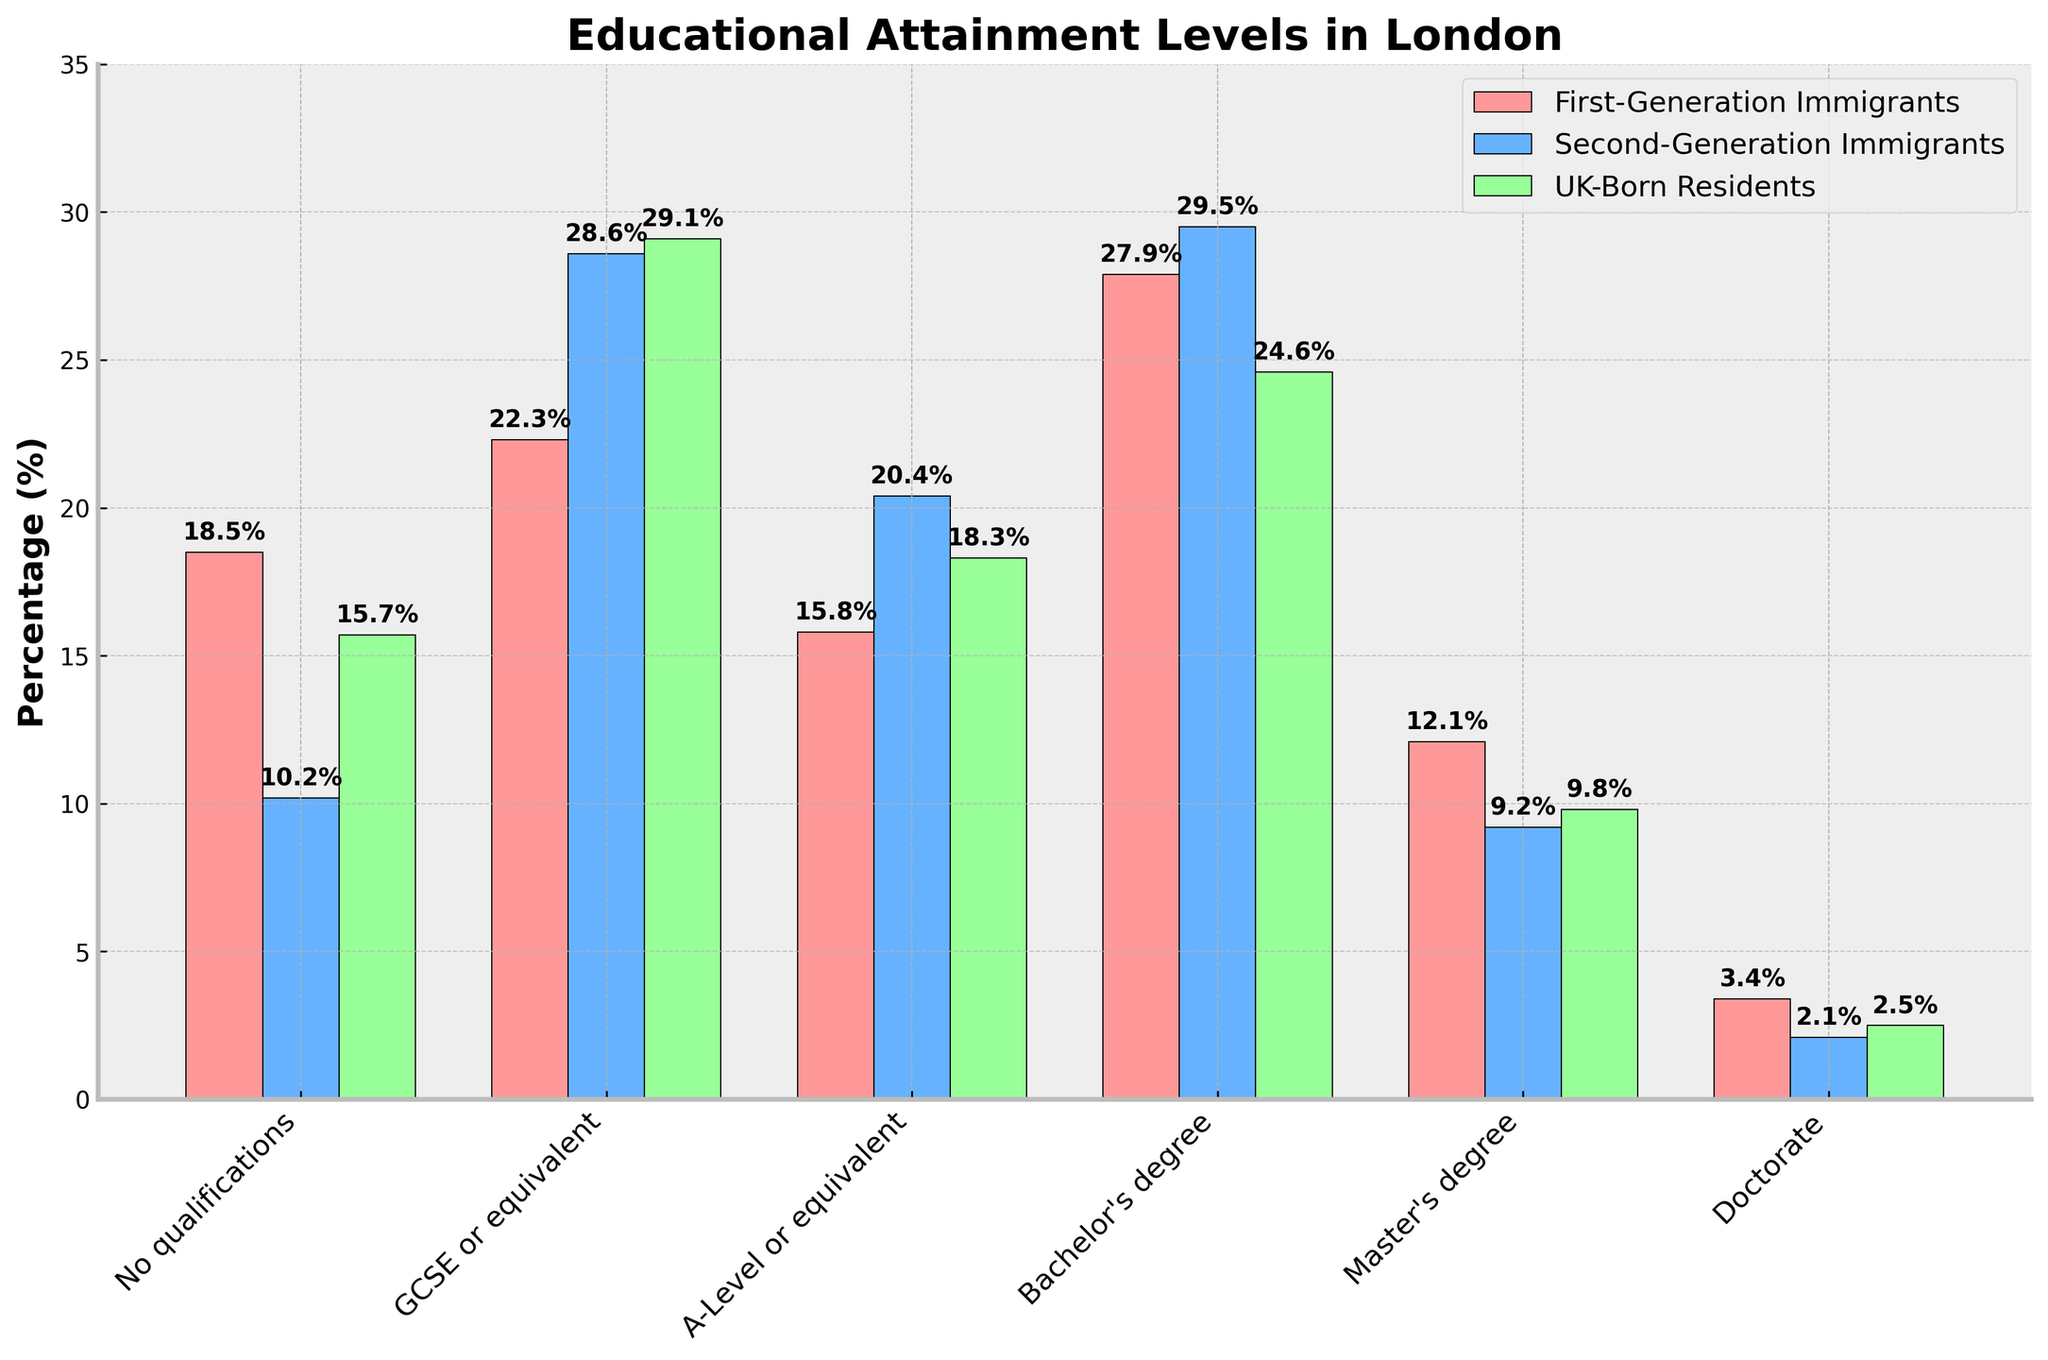What's the highest educational attainment level among second-generation immigrants? By looking at the bar heights for second-generation immigrants, the highest bar corresponds to "Bachelor's degree," indicating it is the highest educational attainment level in this group.
Answer: Bachelor's degree Which group has the highest percentage of people with no qualifications? By comparing the heights of the bars for "No qualifications," we see that first-generation immigrants have the tallest bar, indicating the highest percentage.
Answer: First-Generation Immigrants How do the percentages of first-generation and UK-born residents holding Master's degrees compare? By examining the bars for "Master's degree," first-generation immigrants have 12.1%, whereas UK-born residents have 9.8%. Therefore, a higher percentage of first-generation immigrants hold Master's degrees compared to UK-born residents.
Answer: First-Generation Immigrants have a higher percentage What's the approximate difference in percentage of people with a Bachelor's degree between second-generation immigrants and UK-born residents? The bar for second-generation immigrants is at 29.5%, and the bar for UK-born residents is at 24.6%. The difference is 29.5% - 24.6% = 4.9%.
Answer: 4.9% Which group has the lowest percentage of people holding a Doctorate, and what is that percentage? By examining the bars for "Doctorate," the shortest bar belongs to second-generation immigrants, with a percentage of 2.1%.
Answer: Second-Generation Immigrants, 2.1% How do the percentages of people with A-Levels compare across all three groups? For "A-Level or equivalent," first-generation immigrants have 15.8%, second-generation immigrants have 20.4%, and UK-born residents have 18.3%. Therefore, second-generation immigrants have the highest percentage, followed by UK-born residents, and then first-generation immigrants.
Answer: Second-Generation > UK-Born > First-Generation What is the combined percentage of first-generation immigrants with either a Master's degree or a Doctorate? The percentage for Master's degree is 12.1% and for Doctorate is 3.4%. The combined percentage is 12.1% + 3.4% = 15.5%.
Answer: 15.5% Which group has the highest percentage of people with GCSE or equivalent qualifications? By looking at the bars for "GCSE or equivalent," the tallest bar belongs to UK-born residents at 29.1%.
Answer: UK-Born Residents How does the percentage of second-generation immigrants with no qualifications compare to the percentage of first-generation immigrants with A-Level qualifications? Second-generation immigrants have 10.2% with no qualifications, while first-generation immigrants have 15.8% with A-Level qualifications. Thus, the percentage for first-generation immigrants with A-Level is higher.
Answer: First-Generation Immigrants with A-Level is higher Is there a higher percentage of second-generation immigrants with a Bachelor's degree or a Master's degree? Comparing the bars for Bachelor's and Master's degrees among second-generation immigrants, the Bachelor's degree is at 29.5% and the Master's degree is at 9.2%. Thus, a higher percentage has a Bachelor's degree.
Answer: Bachelor's degree 